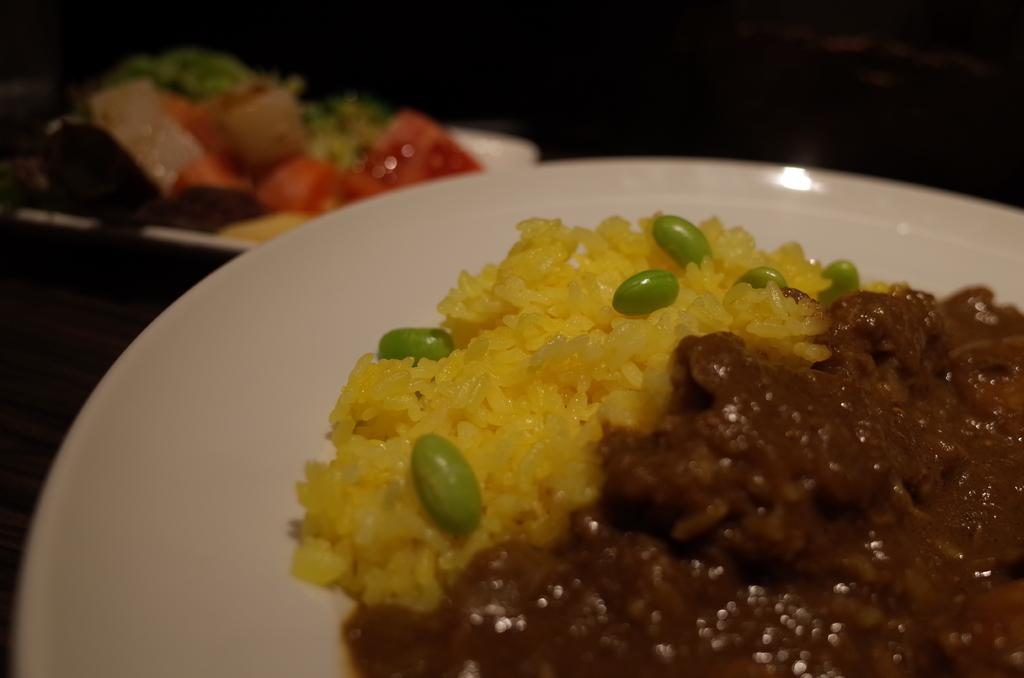What is on the plate that is visible in the image? There is food in a plate in the image. Are there any other plates with food in the image? Yes, there is another plate with food on the table in the image. How do the snails move around on the plate in the image? There are no snails present in the image, so they cannot move around on the plate. 